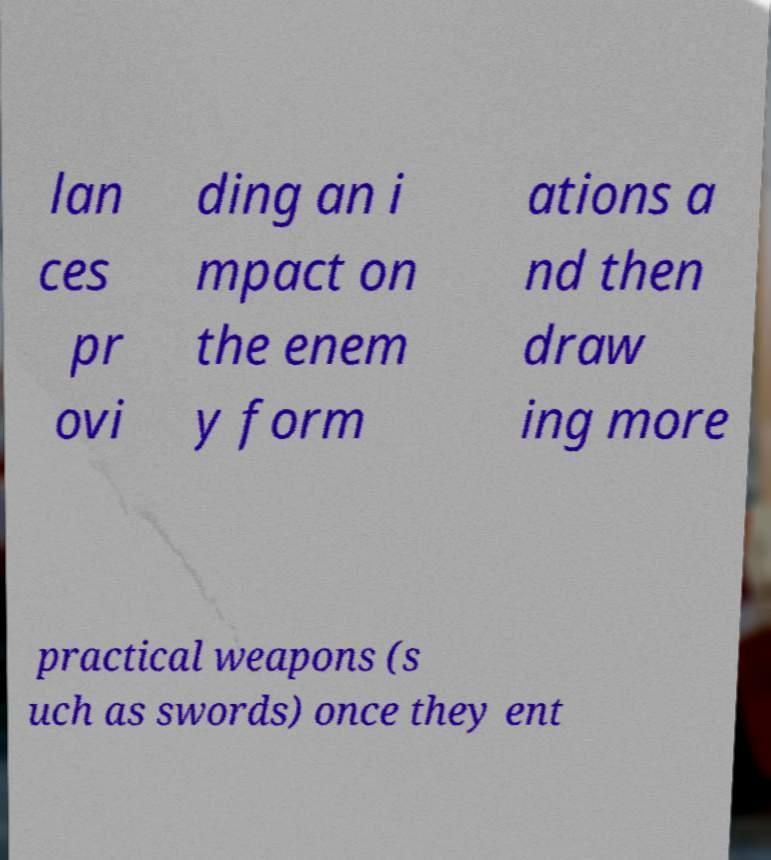For documentation purposes, I need the text within this image transcribed. Could you provide that? lan ces pr ovi ding an i mpact on the enem y form ations a nd then draw ing more practical weapons (s uch as swords) once they ent 